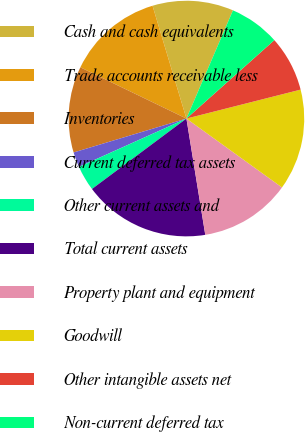<chart> <loc_0><loc_0><loc_500><loc_500><pie_chart><fcel>Cash and cash equivalents<fcel>Trade accounts receivable less<fcel>Inventories<fcel>Current deferred tax assets<fcel>Other current assets and<fcel>Total current assets<fcel>Property plant and equipment<fcel>Goodwill<fcel>Other intangible assets net<fcel>Non-current deferred tax<nl><fcel>11.11%<fcel>13.19%<fcel>11.81%<fcel>2.08%<fcel>3.47%<fcel>17.36%<fcel>12.5%<fcel>13.89%<fcel>7.64%<fcel>6.94%<nl></chart> 